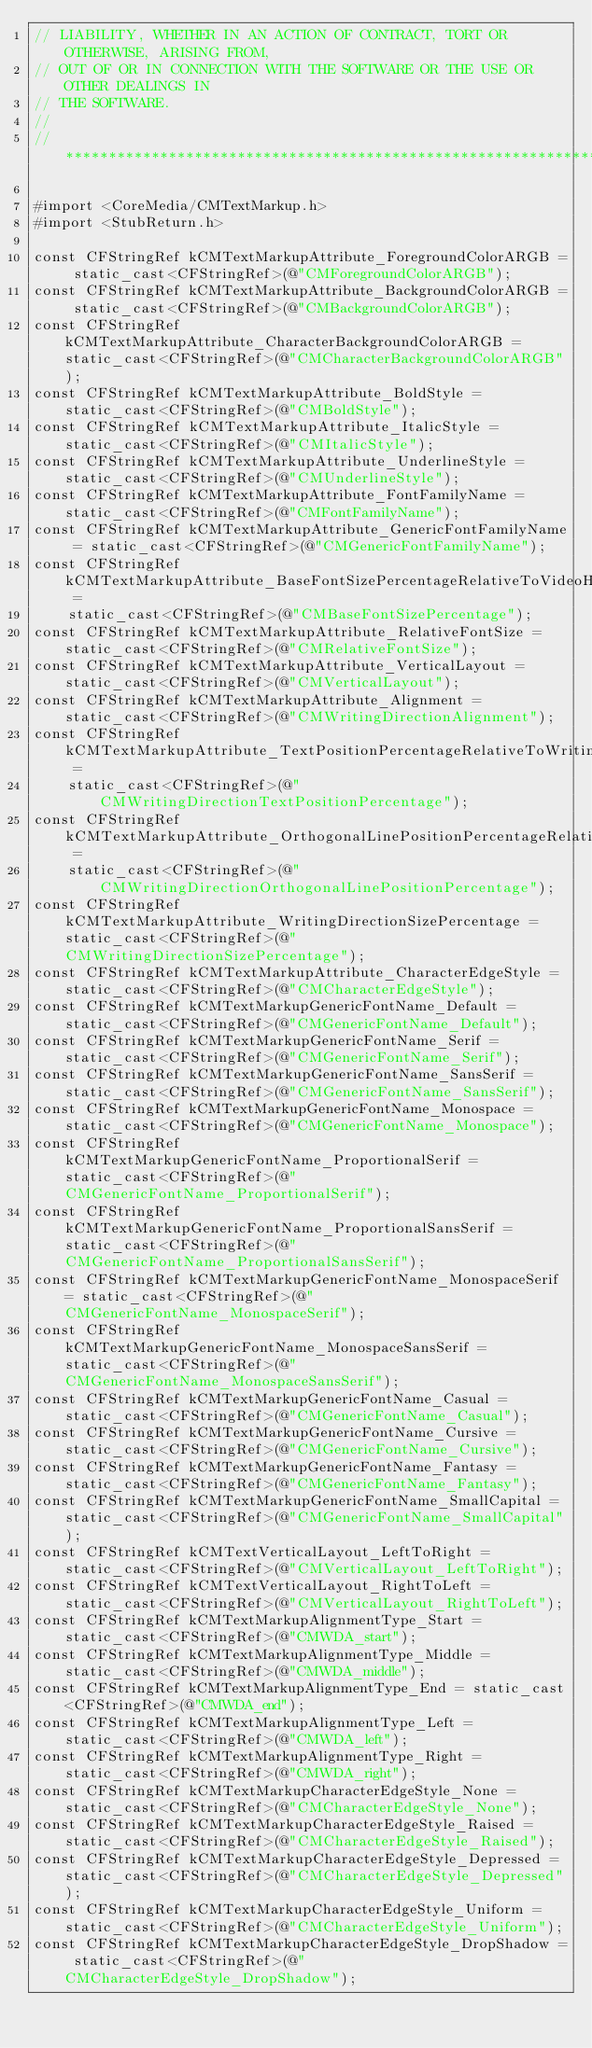Convert code to text. <code><loc_0><loc_0><loc_500><loc_500><_ObjectiveC_>// LIABILITY, WHETHER IN AN ACTION OF CONTRACT, TORT OR OTHERWISE, ARISING FROM,
// OUT OF OR IN CONNECTION WITH THE SOFTWARE OR THE USE OR OTHER DEALINGS IN
// THE SOFTWARE.
//
//******************************************************************************

#import <CoreMedia/CMTextMarkup.h>
#import <StubReturn.h>

const CFStringRef kCMTextMarkupAttribute_ForegroundColorARGB = static_cast<CFStringRef>(@"CMForegroundColorARGB");
const CFStringRef kCMTextMarkupAttribute_BackgroundColorARGB = static_cast<CFStringRef>(@"CMBackgroundColorARGB");
const CFStringRef kCMTextMarkupAttribute_CharacterBackgroundColorARGB = static_cast<CFStringRef>(@"CMCharacterBackgroundColorARGB");
const CFStringRef kCMTextMarkupAttribute_BoldStyle = static_cast<CFStringRef>(@"CMBoldStyle");
const CFStringRef kCMTextMarkupAttribute_ItalicStyle = static_cast<CFStringRef>(@"CMItalicStyle");
const CFStringRef kCMTextMarkupAttribute_UnderlineStyle = static_cast<CFStringRef>(@"CMUnderlineStyle");
const CFStringRef kCMTextMarkupAttribute_FontFamilyName = static_cast<CFStringRef>(@"CMFontFamilyName");
const CFStringRef kCMTextMarkupAttribute_GenericFontFamilyName = static_cast<CFStringRef>(@"CMGenericFontFamilyName");
const CFStringRef kCMTextMarkupAttribute_BaseFontSizePercentageRelativeToVideoHeight =
    static_cast<CFStringRef>(@"CMBaseFontSizePercentage");
const CFStringRef kCMTextMarkupAttribute_RelativeFontSize = static_cast<CFStringRef>(@"CMRelativeFontSize");
const CFStringRef kCMTextMarkupAttribute_VerticalLayout = static_cast<CFStringRef>(@"CMVerticalLayout");
const CFStringRef kCMTextMarkupAttribute_Alignment = static_cast<CFStringRef>(@"CMWritingDirectionAlignment");
const CFStringRef kCMTextMarkupAttribute_TextPositionPercentageRelativeToWritingDirection =
    static_cast<CFStringRef>(@"CMWritingDirectionTextPositionPercentage");
const CFStringRef kCMTextMarkupAttribute_OrthogonalLinePositionPercentageRelativeToWritingDirection =
    static_cast<CFStringRef>(@"CMWritingDirectionOrthogonalLinePositionPercentage");
const CFStringRef kCMTextMarkupAttribute_WritingDirectionSizePercentage = static_cast<CFStringRef>(@"CMWritingDirectionSizePercentage");
const CFStringRef kCMTextMarkupAttribute_CharacterEdgeStyle = static_cast<CFStringRef>(@"CMCharacterEdgeStyle");
const CFStringRef kCMTextMarkupGenericFontName_Default = static_cast<CFStringRef>(@"CMGenericFontName_Default");
const CFStringRef kCMTextMarkupGenericFontName_Serif = static_cast<CFStringRef>(@"CMGenericFontName_Serif");
const CFStringRef kCMTextMarkupGenericFontName_SansSerif = static_cast<CFStringRef>(@"CMGenericFontName_SansSerif");
const CFStringRef kCMTextMarkupGenericFontName_Monospace = static_cast<CFStringRef>(@"CMGenericFontName_Monospace");
const CFStringRef kCMTextMarkupGenericFontName_ProportionalSerif = static_cast<CFStringRef>(@"CMGenericFontName_ProportionalSerif");
const CFStringRef kCMTextMarkupGenericFontName_ProportionalSansSerif = static_cast<CFStringRef>(@"CMGenericFontName_ProportionalSansSerif");
const CFStringRef kCMTextMarkupGenericFontName_MonospaceSerif = static_cast<CFStringRef>(@"CMGenericFontName_MonospaceSerif");
const CFStringRef kCMTextMarkupGenericFontName_MonospaceSansSerif = static_cast<CFStringRef>(@"CMGenericFontName_MonospaceSansSerif");
const CFStringRef kCMTextMarkupGenericFontName_Casual = static_cast<CFStringRef>(@"CMGenericFontName_Casual");
const CFStringRef kCMTextMarkupGenericFontName_Cursive = static_cast<CFStringRef>(@"CMGenericFontName_Cursive");
const CFStringRef kCMTextMarkupGenericFontName_Fantasy = static_cast<CFStringRef>(@"CMGenericFontName_Fantasy");
const CFStringRef kCMTextMarkupGenericFontName_SmallCapital = static_cast<CFStringRef>(@"CMGenericFontName_SmallCapital");
const CFStringRef kCMTextVerticalLayout_LeftToRight = static_cast<CFStringRef>(@"CMVerticalLayout_LeftToRight");
const CFStringRef kCMTextVerticalLayout_RightToLeft = static_cast<CFStringRef>(@"CMVerticalLayout_RightToLeft");
const CFStringRef kCMTextMarkupAlignmentType_Start = static_cast<CFStringRef>(@"CMWDA_start");
const CFStringRef kCMTextMarkupAlignmentType_Middle = static_cast<CFStringRef>(@"CMWDA_middle");
const CFStringRef kCMTextMarkupAlignmentType_End = static_cast<CFStringRef>(@"CMWDA_end");
const CFStringRef kCMTextMarkupAlignmentType_Left = static_cast<CFStringRef>(@"CMWDA_left");
const CFStringRef kCMTextMarkupAlignmentType_Right = static_cast<CFStringRef>(@"CMWDA_right");
const CFStringRef kCMTextMarkupCharacterEdgeStyle_None = static_cast<CFStringRef>(@"CMCharacterEdgeStyle_None");
const CFStringRef kCMTextMarkupCharacterEdgeStyle_Raised = static_cast<CFStringRef>(@"CMCharacterEdgeStyle_Raised");
const CFStringRef kCMTextMarkupCharacterEdgeStyle_Depressed = static_cast<CFStringRef>(@"CMCharacterEdgeStyle_Depressed");
const CFStringRef kCMTextMarkupCharacterEdgeStyle_Uniform = static_cast<CFStringRef>(@"CMCharacterEdgeStyle_Uniform");
const CFStringRef kCMTextMarkupCharacterEdgeStyle_DropShadow = static_cast<CFStringRef>(@"CMCharacterEdgeStyle_DropShadow");</code> 